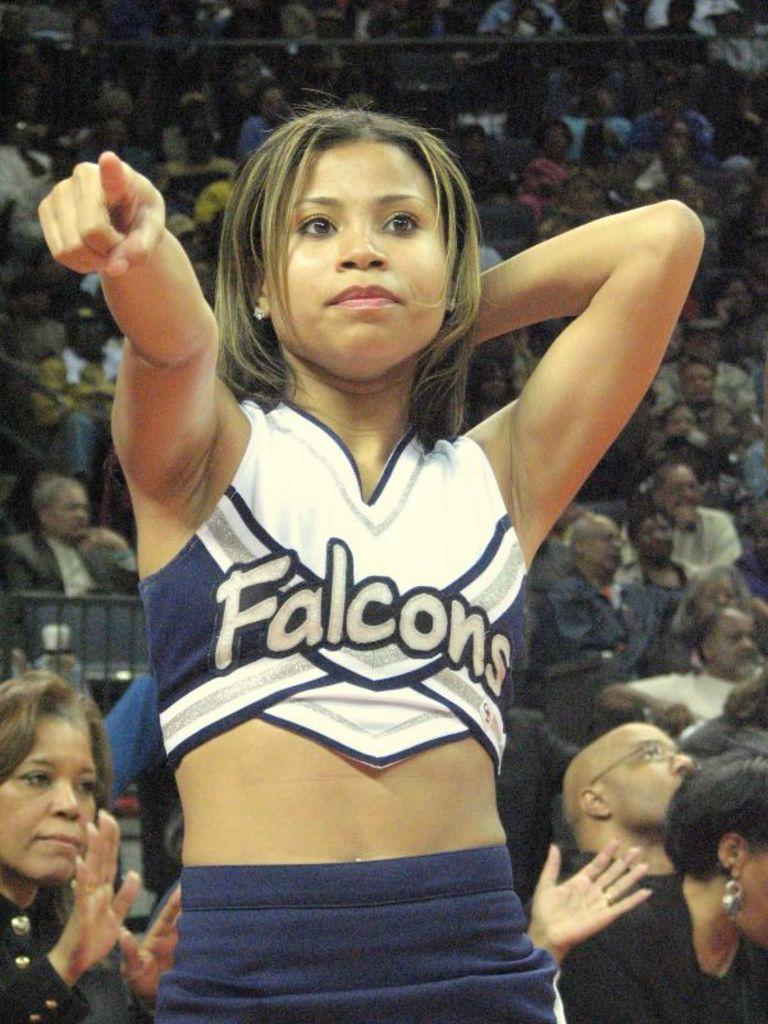<image>
Offer a succinct explanation of the picture presented. A cheerleader is wearing a top that says Falcons and pointing by a crowd. 